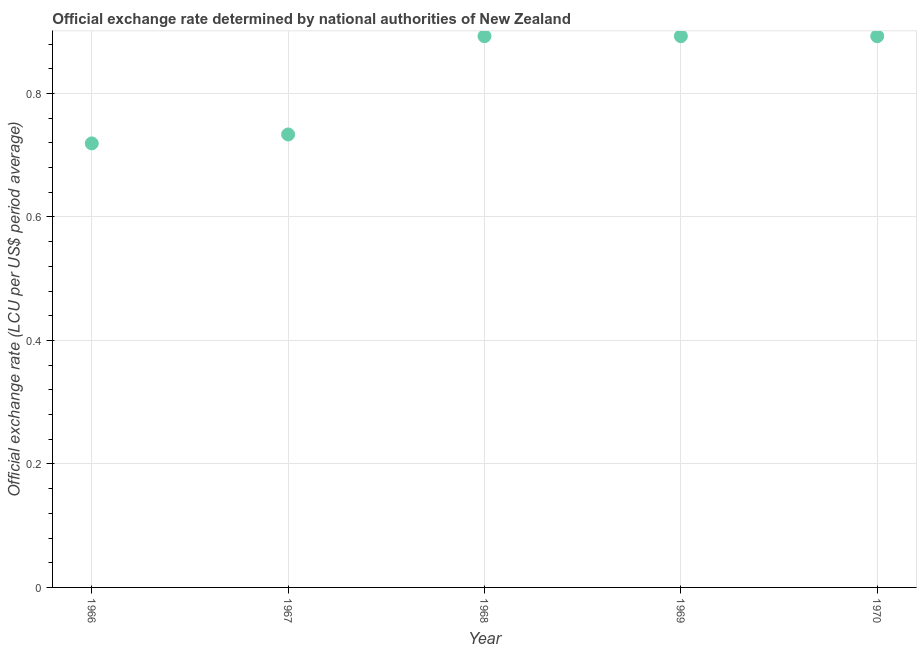What is the official exchange rate in 1966?
Give a very brief answer. 0.72. Across all years, what is the maximum official exchange rate?
Make the answer very short. 0.89. Across all years, what is the minimum official exchange rate?
Your response must be concise. 0.72. In which year was the official exchange rate maximum?
Keep it short and to the point. 1968. In which year was the official exchange rate minimum?
Offer a terse response. 1966. What is the sum of the official exchange rate?
Your response must be concise. 4.13. What is the difference between the official exchange rate in 1967 and 1968?
Offer a terse response. -0.16. What is the average official exchange rate per year?
Make the answer very short. 0.83. What is the median official exchange rate?
Provide a short and direct response. 0.89. What is the ratio of the official exchange rate in 1966 to that in 1970?
Make the answer very short. 0.81. Is the official exchange rate in 1966 less than that in 1969?
Offer a very short reply. Yes. Is the difference between the official exchange rate in 1967 and 1969 greater than the difference between any two years?
Give a very brief answer. No. What is the difference between the highest and the second highest official exchange rate?
Offer a terse response. 0. What is the difference between the highest and the lowest official exchange rate?
Your answer should be compact. 0.17. How many dotlines are there?
Offer a very short reply. 1. Are the values on the major ticks of Y-axis written in scientific E-notation?
Offer a very short reply. No. Does the graph contain any zero values?
Your answer should be compact. No. What is the title of the graph?
Make the answer very short. Official exchange rate determined by national authorities of New Zealand. What is the label or title of the Y-axis?
Your answer should be very brief. Official exchange rate (LCU per US$ period average). What is the Official exchange rate (LCU per US$ period average) in 1966?
Provide a short and direct response. 0.72. What is the Official exchange rate (LCU per US$ period average) in 1967?
Provide a short and direct response. 0.73. What is the Official exchange rate (LCU per US$ period average) in 1968?
Your response must be concise. 0.89. What is the Official exchange rate (LCU per US$ period average) in 1969?
Give a very brief answer. 0.89. What is the Official exchange rate (LCU per US$ period average) in 1970?
Provide a short and direct response. 0.89. What is the difference between the Official exchange rate (LCU per US$ period average) in 1966 and 1967?
Offer a very short reply. -0.01. What is the difference between the Official exchange rate (LCU per US$ period average) in 1966 and 1968?
Your answer should be compact. -0.17. What is the difference between the Official exchange rate (LCU per US$ period average) in 1966 and 1969?
Provide a succinct answer. -0.17. What is the difference between the Official exchange rate (LCU per US$ period average) in 1966 and 1970?
Your response must be concise. -0.17. What is the difference between the Official exchange rate (LCU per US$ period average) in 1967 and 1968?
Your answer should be compact. -0.16. What is the difference between the Official exchange rate (LCU per US$ period average) in 1967 and 1969?
Ensure brevity in your answer.  -0.16. What is the difference between the Official exchange rate (LCU per US$ period average) in 1967 and 1970?
Keep it short and to the point. -0.16. What is the difference between the Official exchange rate (LCU per US$ period average) in 1968 and 1970?
Your answer should be compact. 0. What is the ratio of the Official exchange rate (LCU per US$ period average) in 1966 to that in 1967?
Make the answer very short. 0.98. What is the ratio of the Official exchange rate (LCU per US$ period average) in 1966 to that in 1968?
Provide a short and direct response. 0.81. What is the ratio of the Official exchange rate (LCU per US$ period average) in 1966 to that in 1969?
Your answer should be very brief. 0.81. What is the ratio of the Official exchange rate (LCU per US$ period average) in 1966 to that in 1970?
Ensure brevity in your answer.  0.81. What is the ratio of the Official exchange rate (LCU per US$ period average) in 1967 to that in 1968?
Your answer should be very brief. 0.82. What is the ratio of the Official exchange rate (LCU per US$ period average) in 1967 to that in 1969?
Offer a terse response. 0.82. What is the ratio of the Official exchange rate (LCU per US$ period average) in 1967 to that in 1970?
Provide a short and direct response. 0.82. What is the ratio of the Official exchange rate (LCU per US$ period average) in 1968 to that in 1969?
Your answer should be compact. 1. 